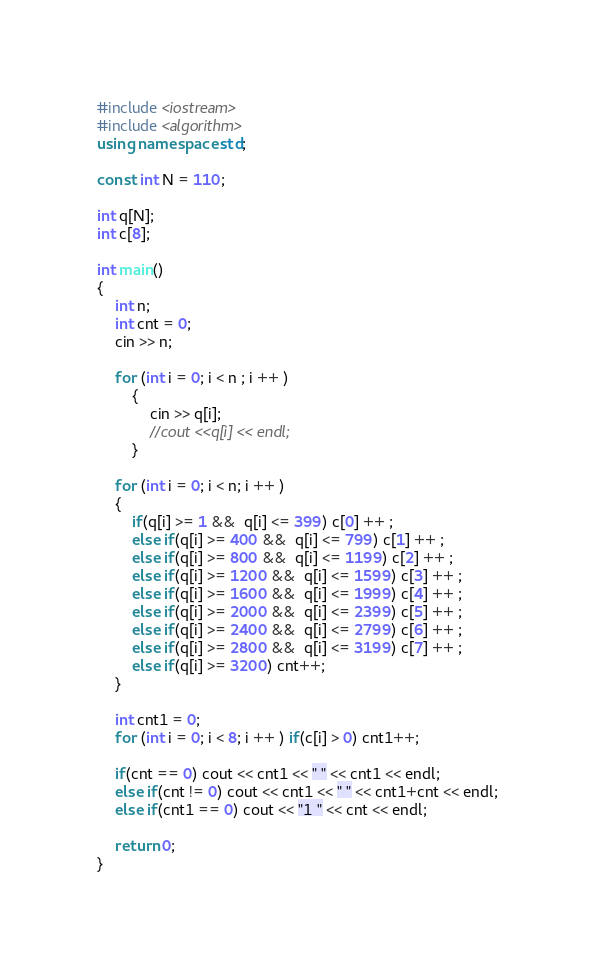<code> <loc_0><loc_0><loc_500><loc_500><_C++_>#include <iostream>
#include <algorithm>
using namespace std;

const int N = 110;

int q[N];
int c[8];

int main()
{
    int n;
    int cnt = 0;
    cin >> n;

    for (int i = 0; i < n ; i ++ )
        {
            cin >> q[i];
            //cout <<q[i] << endl;
        }

    for (int i = 0; i < n; i ++ )
    {
        if(q[i] >= 1 &&  q[i] <= 399) c[0] ++ ;
        else if(q[i] >= 400 &&  q[i] <= 799) c[1] ++ ;
        else if(q[i] >= 800 &&  q[i] <= 1199) c[2] ++ ;
        else if(q[i] >= 1200 &&  q[i] <= 1599) c[3] ++ ;
        else if(q[i] >= 1600 &&  q[i] <= 1999) c[4] ++ ;
        else if(q[i] >= 2000 &&  q[i] <= 2399) c[5] ++ ;
        else if(q[i] >= 2400 &&  q[i] <= 2799) c[6] ++ ;
        else if(q[i] >= 2800 &&  q[i] <= 3199) c[7] ++ ;
        else if(q[i] >= 3200) cnt++;
    }

    int cnt1 = 0;
    for (int i = 0; i < 8; i ++ ) if(c[i] > 0) cnt1++;

    if(cnt == 0) cout << cnt1 << " " << cnt1 << endl;
    else if(cnt != 0) cout << cnt1 << " " << cnt1+cnt << endl;
    else if(cnt1 == 0) cout << "1 " << cnt << endl;

    return 0;
}
</code> 